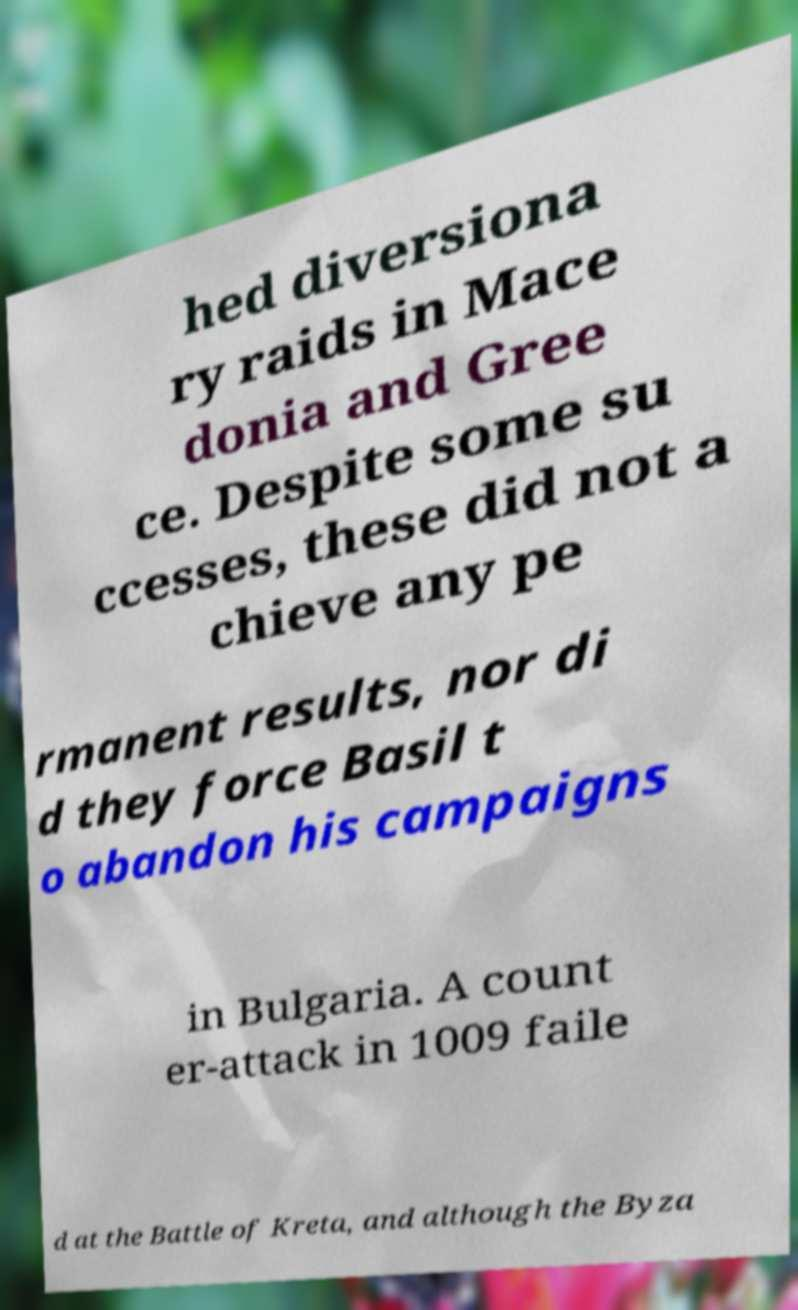I need the written content from this picture converted into text. Can you do that? hed diversiona ry raids in Mace donia and Gree ce. Despite some su ccesses, these did not a chieve any pe rmanent results, nor di d they force Basil t o abandon his campaigns in Bulgaria. A count er-attack in 1009 faile d at the Battle of Kreta, and although the Byza 